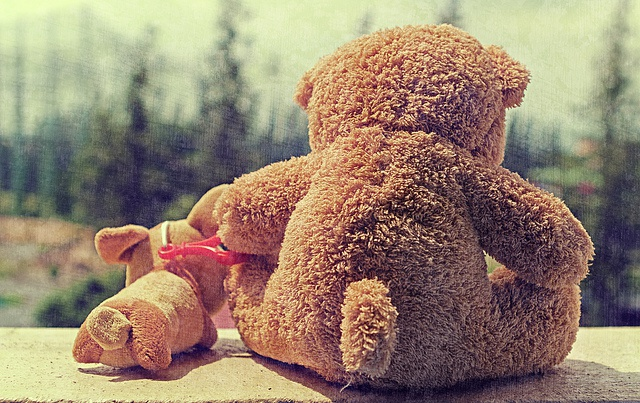Describe the objects in this image and their specific colors. I can see teddy bear in lightyellow, brown, tan, and maroon tones and teddy bear in lightyellow, brown, tan, khaki, and salmon tones in this image. 